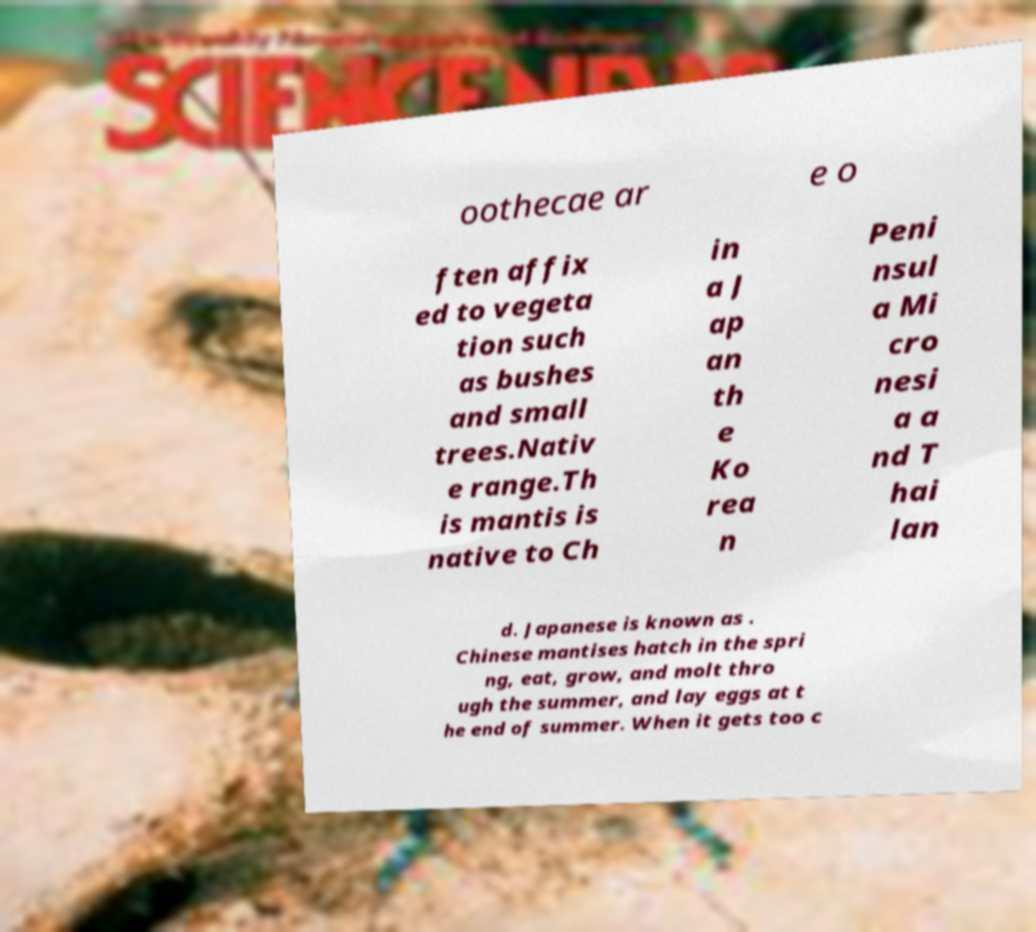I need the written content from this picture converted into text. Can you do that? oothecae ar e o ften affix ed to vegeta tion such as bushes and small trees.Nativ e range.Th is mantis is native to Ch in a J ap an th e Ko rea n Peni nsul a Mi cro nesi a a nd T hai lan d. Japanese is known as . Chinese mantises hatch in the spri ng, eat, grow, and molt thro ugh the summer, and lay eggs at t he end of summer. When it gets too c 